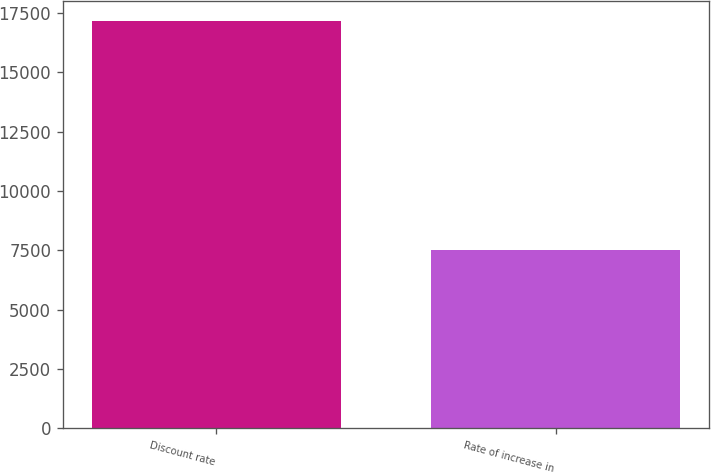Convert chart to OTSL. <chart><loc_0><loc_0><loc_500><loc_500><bar_chart><fcel>Discount rate<fcel>Rate of increase in<nl><fcel>17145<fcel>7503<nl></chart> 